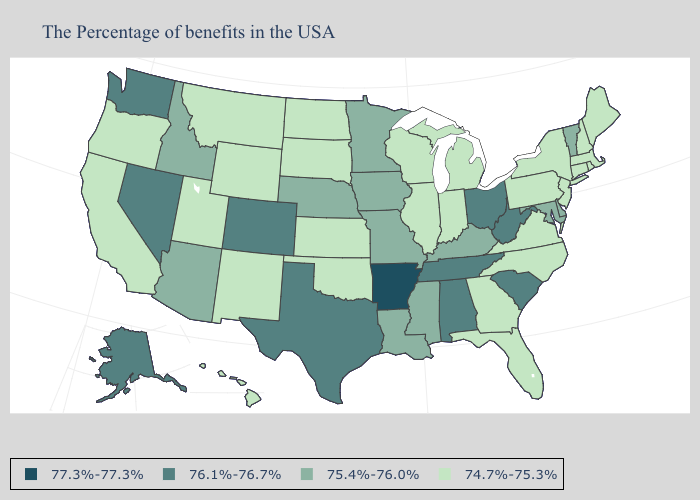Which states have the lowest value in the Northeast?
Quick response, please. Maine, Massachusetts, Rhode Island, New Hampshire, Connecticut, New York, New Jersey, Pennsylvania. Which states hav the highest value in the South?
Give a very brief answer. Arkansas. Name the states that have a value in the range 76.1%-76.7%?
Give a very brief answer. South Carolina, West Virginia, Ohio, Alabama, Tennessee, Texas, Colorado, Nevada, Washington, Alaska. Among the states that border Rhode Island , which have the highest value?
Write a very short answer. Massachusetts, Connecticut. Name the states that have a value in the range 77.3%-77.3%?
Answer briefly. Arkansas. Among the states that border Missouri , does Arkansas have the highest value?
Write a very short answer. Yes. What is the value of South Dakota?
Keep it brief. 74.7%-75.3%. Does Kentucky have the lowest value in the South?
Be succinct. No. What is the lowest value in the West?
Concise answer only. 74.7%-75.3%. What is the lowest value in the USA?
Keep it brief. 74.7%-75.3%. Among the states that border Utah , which have the highest value?
Short answer required. Colorado, Nevada. Name the states that have a value in the range 77.3%-77.3%?
Be succinct. Arkansas. Name the states that have a value in the range 77.3%-77.3%?
Write a very short answer. Arkansas. Does Arkansas have the highest value in the USA?
Keep it brief. Yes. 